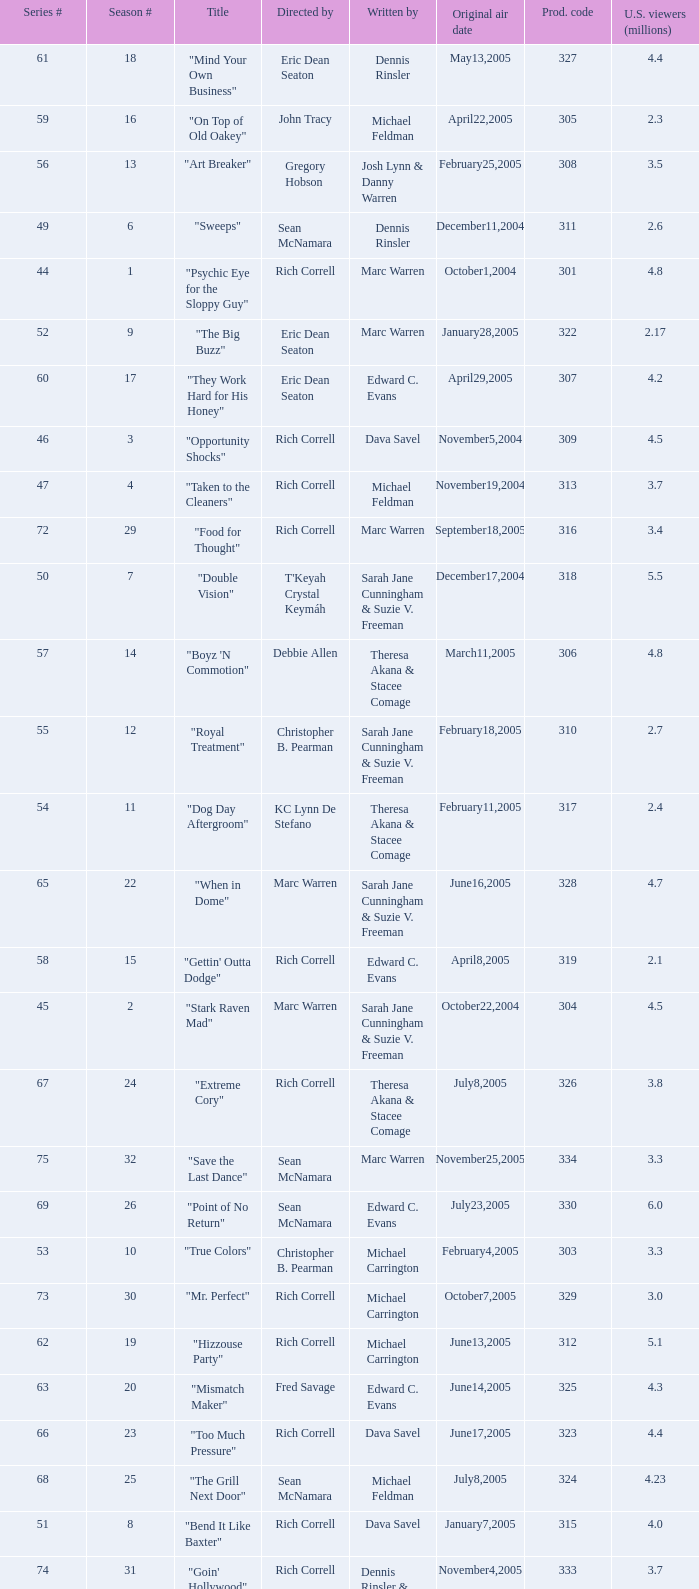What is the title of the episode directed by Rich Correll and written by Dennis Rinsler? "Five Finger Discount". 